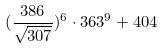Convert formula to latex. <formula><loc_0><loc_0><loc_500><loc_500>( \frac { 3 8 6 } { \sqrt { 3 0 7 } } ) ^ { 6 } \cdot 3 6 3 ^ { 9 } + 4 0 4</formula> 